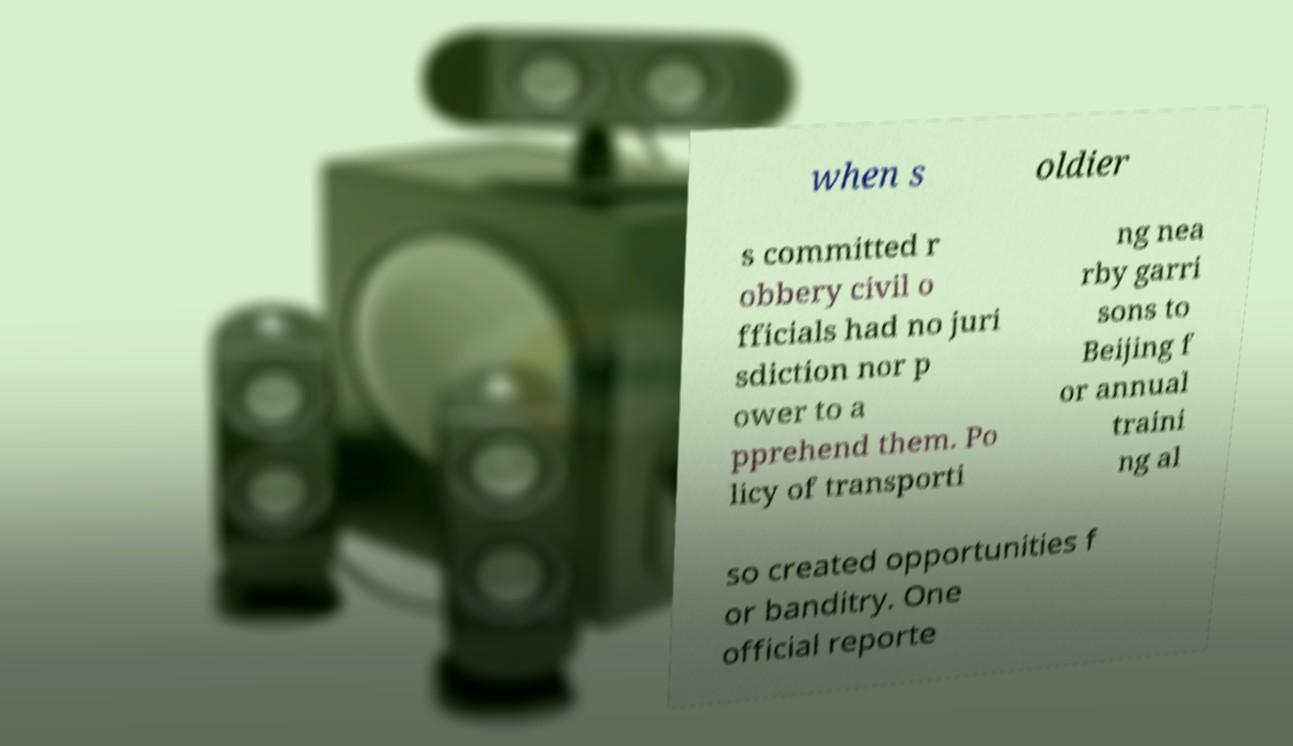Could you extract and type out the text from this image? when s oldier s committed r obbery civil o fficials had no juri sdiction nor p ower to a pprehend them. Po licy of transporti ng nea rby garri sons to Beijing f or annual traini ng al so created opportunities f or banditry. One official reporte 